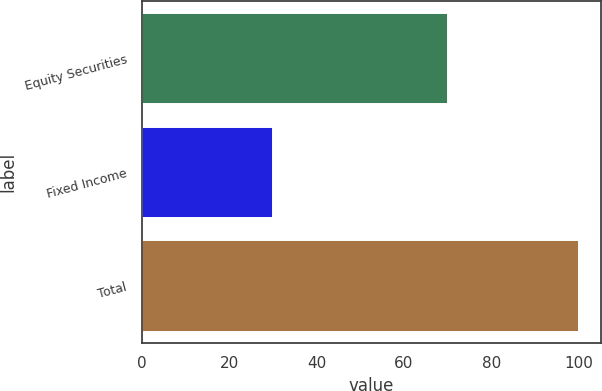Convert chart to OTSL. <chart><loc_0><loc_0><loc_500><loc_500><bar_chart><fcel>Equity Securities<fcel>Fixed Income<fcel>Total<nl><fcel>70<fcel>30<fcel>100<nl></chart> 